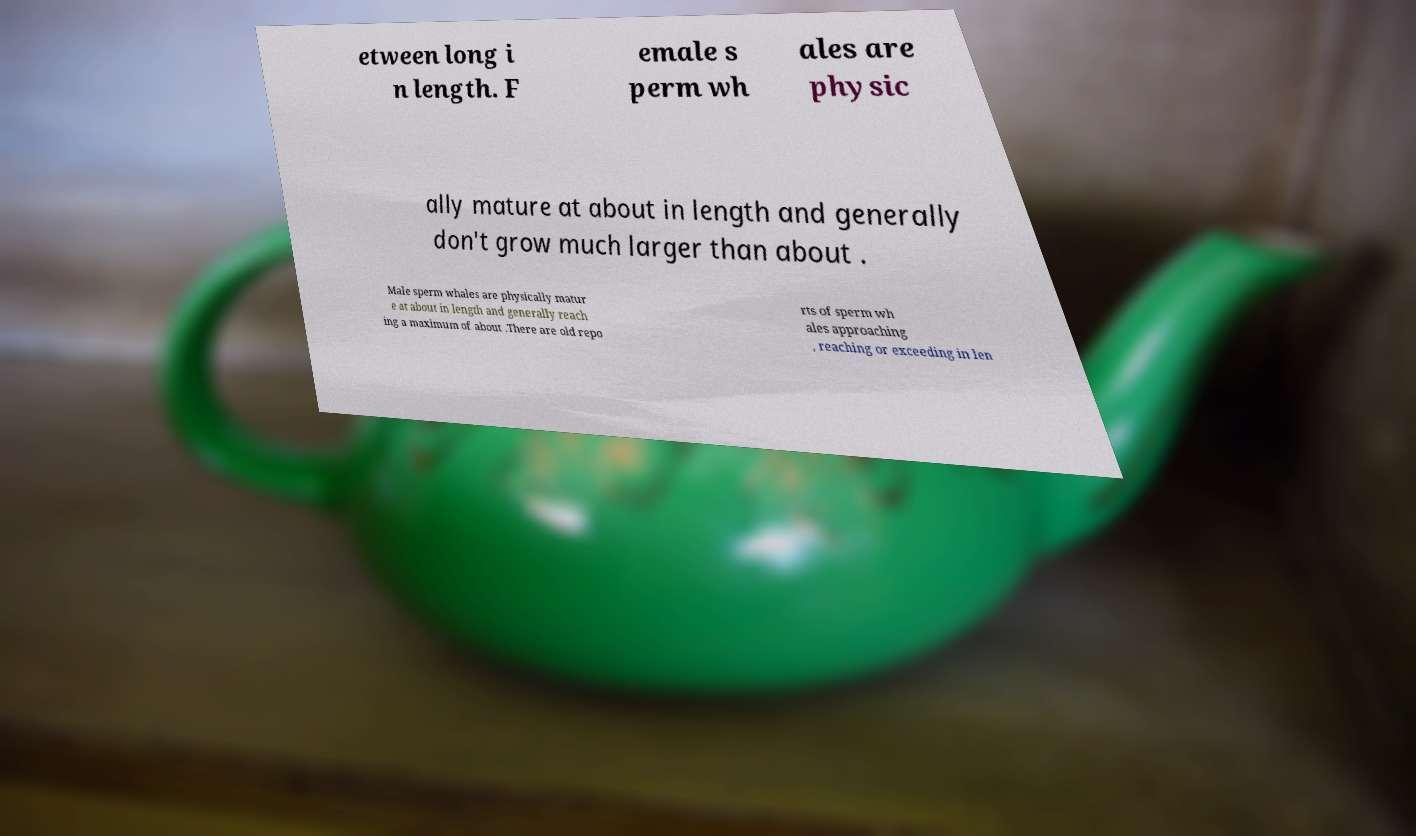Please identify and transcribe the text found in this image. etween long i n length. F emale s perm wh ales are physic ally mature at about in length and generally don't grow much larger than about . Male sperm whales are physically matur e at about in length and generally reach ing a maximum of about .There are old repo rts of sperm wh ales approaching , reaching or exceeding in len 